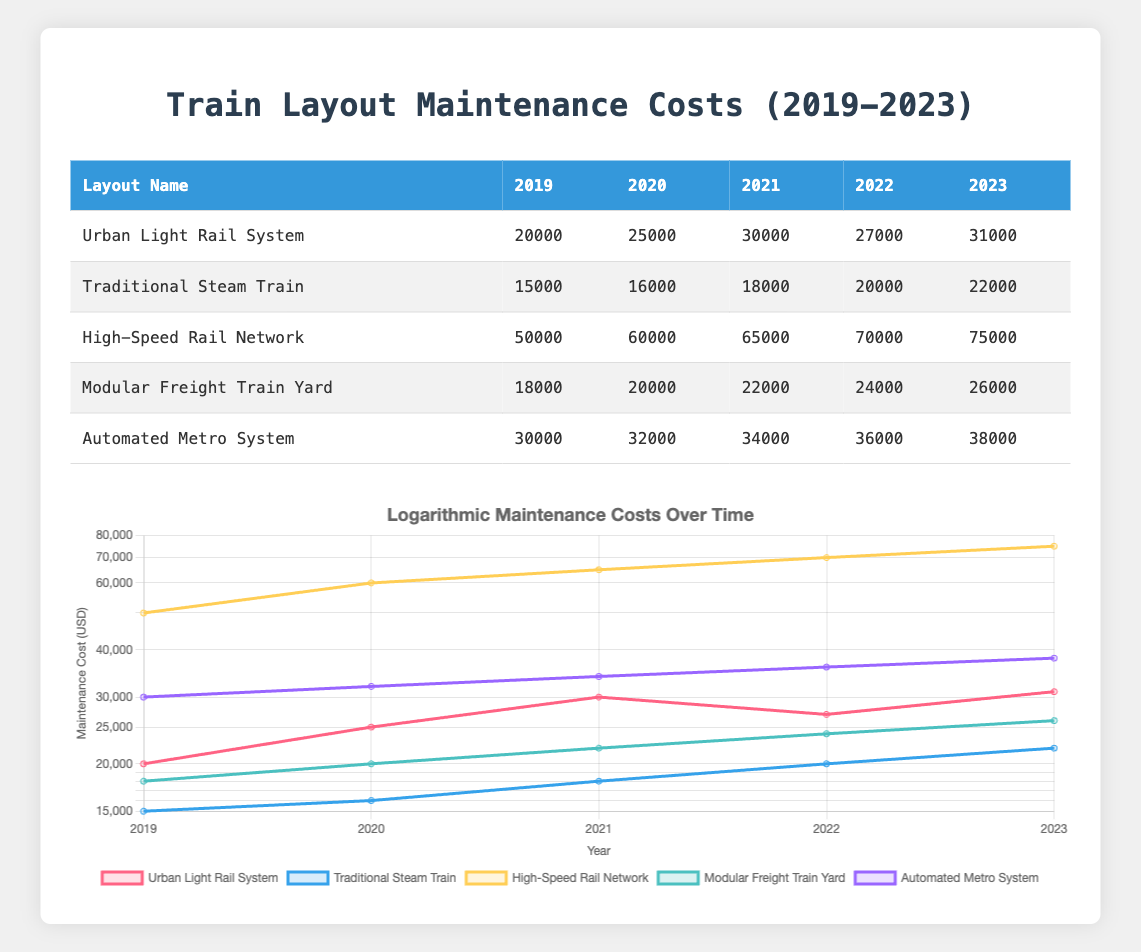What were the maintenance costs for the High-Speed Rail Network in 2021? The table shows the annual maintenance costs for the High-Speed Rail Network, specifically indicating that in 2021, the cost was 65000.
Answer: 65000 Which layout had the lowest maintenance cost in 2019? By examining the first column for layout names and the 2019 column for costs, the Traditional Steam Train had the lowest cost at 15000.
Answer: 15000 What is the average maintenance cost for the Urban Light Rail System over the years 2019 to 2023? The costs for the Urban Light Rail System are 20000, 25000, 30000, 27000, and 31000. Summing these values gives 20000 + 25000 + 30000 + 27000 + 31000 = 133000. Dividing by the number of years, 5, gives 133000 / 5 = 26600.
Answer: 26600 Did the maintenance costs for the Automated Metro System increase every year from 2019 to 2023? The costs for the Automated Metro System are 30000 for 2019, 32000 for 2020, 34000 for 2021, 36000 for 2022, and finally 38000 for 2023. Since each cost is greater than the previous year's, the costs did indeed increase every year.
Answer: Yes What was the total maintenance cost across all layouts for the year 2022? The maintenance costs for 2022 are as follows: Urban Light Rail System: 27000, Traditional Steam Train: 20000, High-Speed Rail Network: 70000, Modular Freight Train Yard: 24000, and Automated Metro System: 36000. Summing these values gives 27000 + 20000 + 70000 + 24000 + 36000 = 177000.
Answer: 177000 Which layout had the highest maintenance cost in the most recent year, 2023? Looking at the last column for 2023, the High-Speed Rail Network shows the highest maintenance cost at 75000 compared to all other layouts.
Answer: 75000 What was the difference in maintenance costs between the Traditional Steam Train and the Modular Freight Train Yard in 2023? The costs in 2023 are 22000 for the Traditional Steam Train and 26000 for the Modular Freight Train Yard. The difference is calculated as 26000 - 22000 = 4000.
Answer: 4000 How much did the maintenance costs for the High-Speed Rail Network increase from 2019 to 2023? The maintenance costs for the High-Speed Rail Network in 2019 were 50000 and in 2023 were 75000. The increase is calculated as 75000 - 50000 = 25000.
Answer: 25000 What percentage increase did the Automated Metro System's maintenance costs see from 2019 to 2023? The cost in 2019 was 30000 and in 2023 was 38000. The increase is 38000 - 30000 = 8000. To find the percentage increase, divide the increase (8000) by the original cost (30000) and multiply by 100: (8000 / 30000) * 100 = 26.67.
Answer: 26.67 